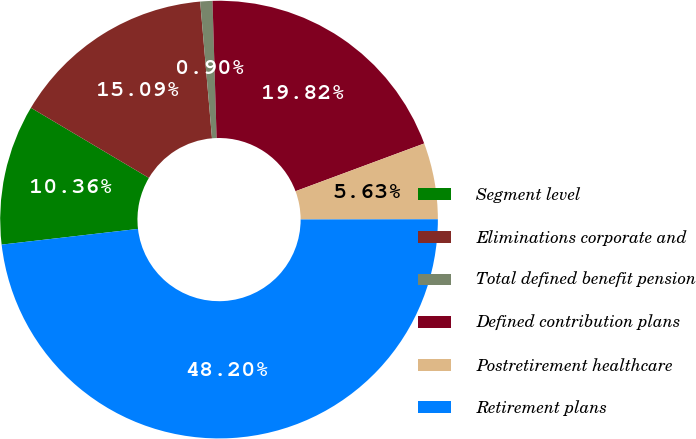Convert chart. <chart><loc_0><loc_0><loc_500><loc_500><pie_chart><fcel>Segment level<fcel>Eliminations corporate and<fcel>Total defined benefit pension<fcel>Defined contribution plans<fcel>Postretirement healthcare<fcel>Retirement plans<nl><fcel>10.36%<fcel>15.09%<fcel>0.9%<fcel>19.82%<fcel>5.63%<fcel>48.2%<nl></chart> 